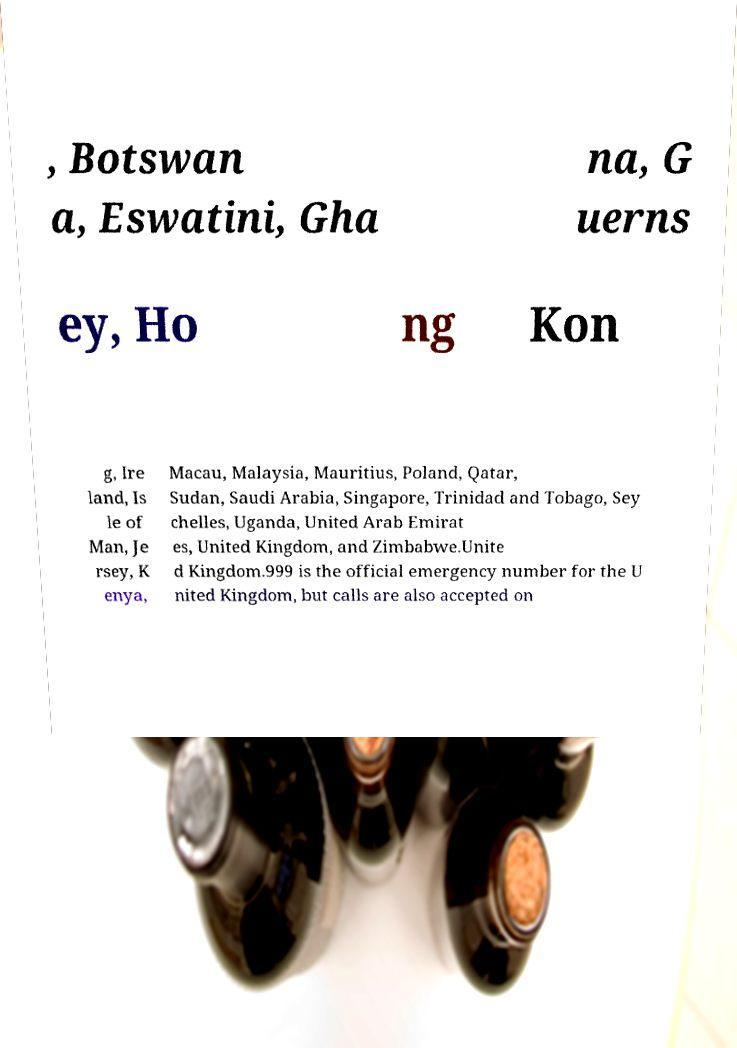Could you extract and type out the text from this image? , Botswan a, Eswatini, Gha na, G uerns ey, Ho ng Kon g, Ire land, Is le of Man, Je rsey, K enya, Macau, Malaysia, Mauritius, Poland, Qatar, Sudan, Saudi Arabia, Singapore, Trinidad and Tobago, Sey chelles, Uganda, United Arab Emirat es, United Kingdom, and Zimbabwe.Unite d Kingdom.999 is the official emergency number for the U nited Kingdom, but calls are also accepted on 